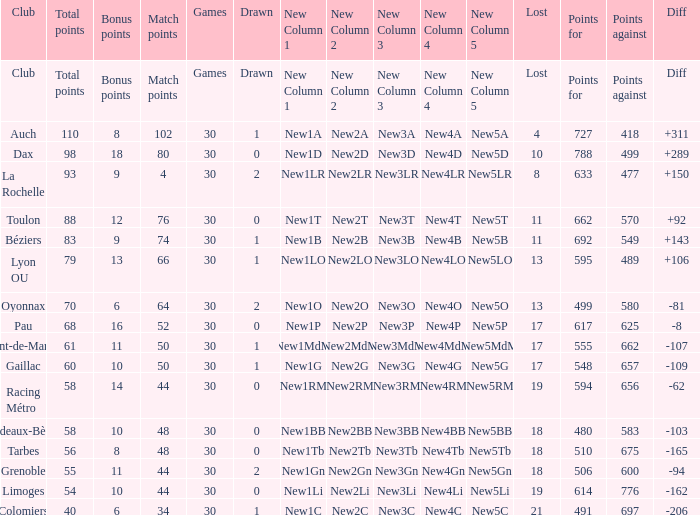What is the number of games for a club that has a value of 595 for points for? 30.0. 